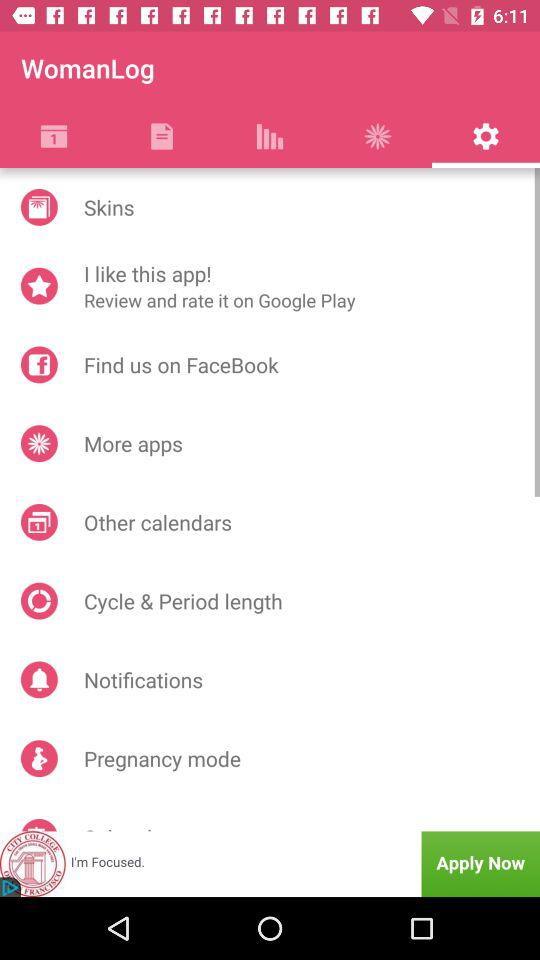Which tab am I on? You are on the "Settings" tab. 